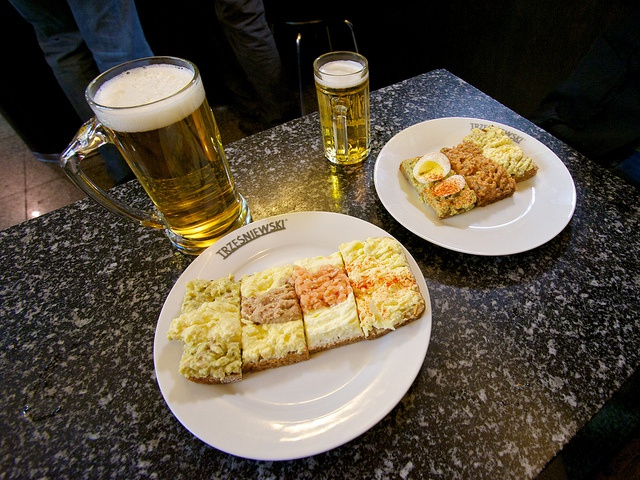Describe the objects in this image and their specific colors. I can see dining table in black, lightgray, gray, and tan tones, people in black, navy, darkblue, and darkgreen tones, cup in black, maroon, olive, and lightgray tones, sandwich in black, khaki, orange, and tan tones, and cup in black, olive, maroon, and lightgray tones in this image. 